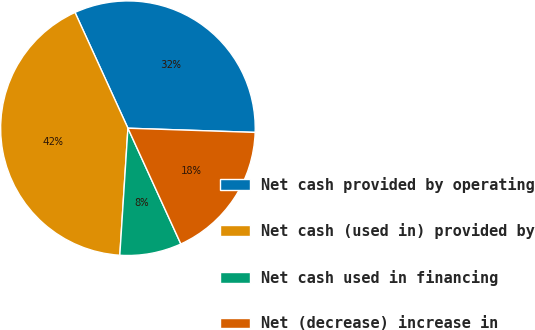Convert chart to OTSL. <chart><loc_0><loc_0><loc_500><loc_500><pie_chart><fcel>Net cash provided by operating<fcel>Net cash (used in) provided by<fcel>Net cash used in financing<fcel>Net (decrease) increase in<nl><fcel>32.35%<fcel>42.16%<fcel>7.84%<fcel>17.65%<nl></chart> 